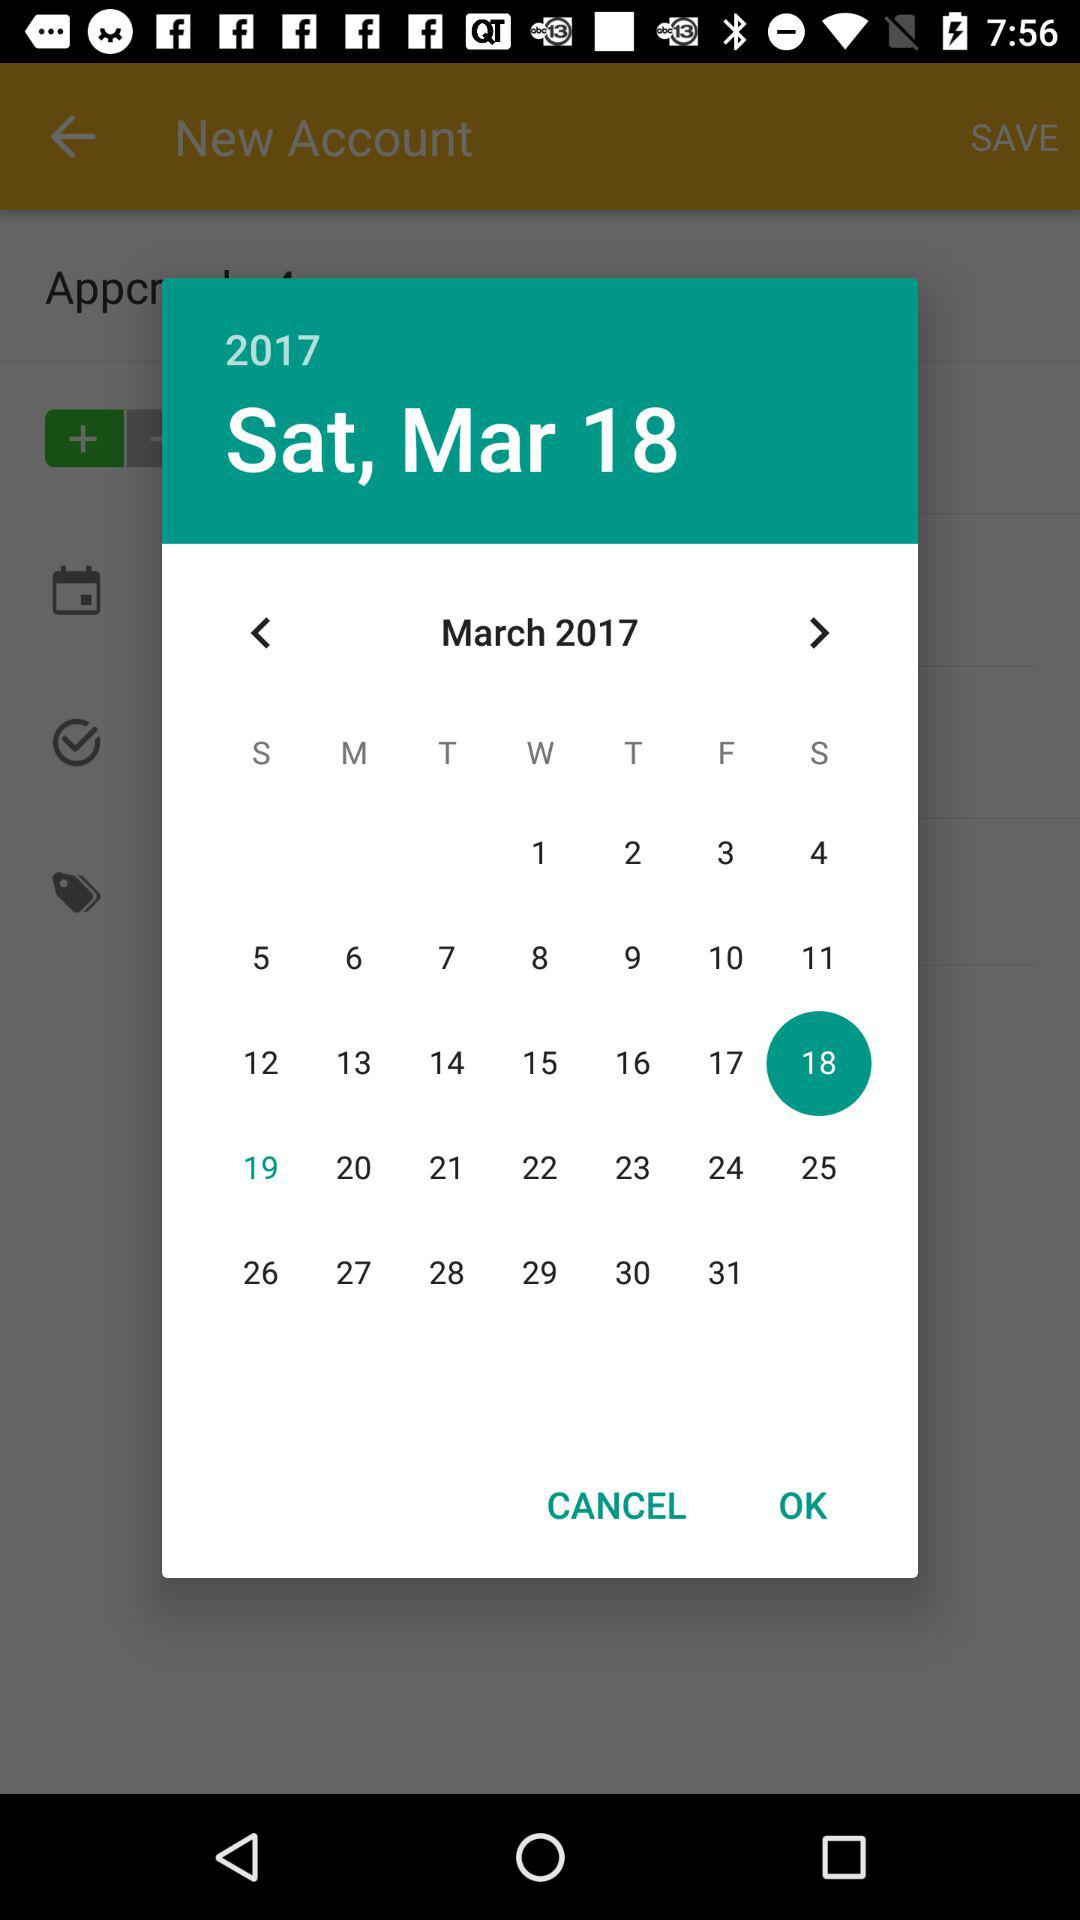What is the selected date? The selected date is Saturday, March 18, 2017. 